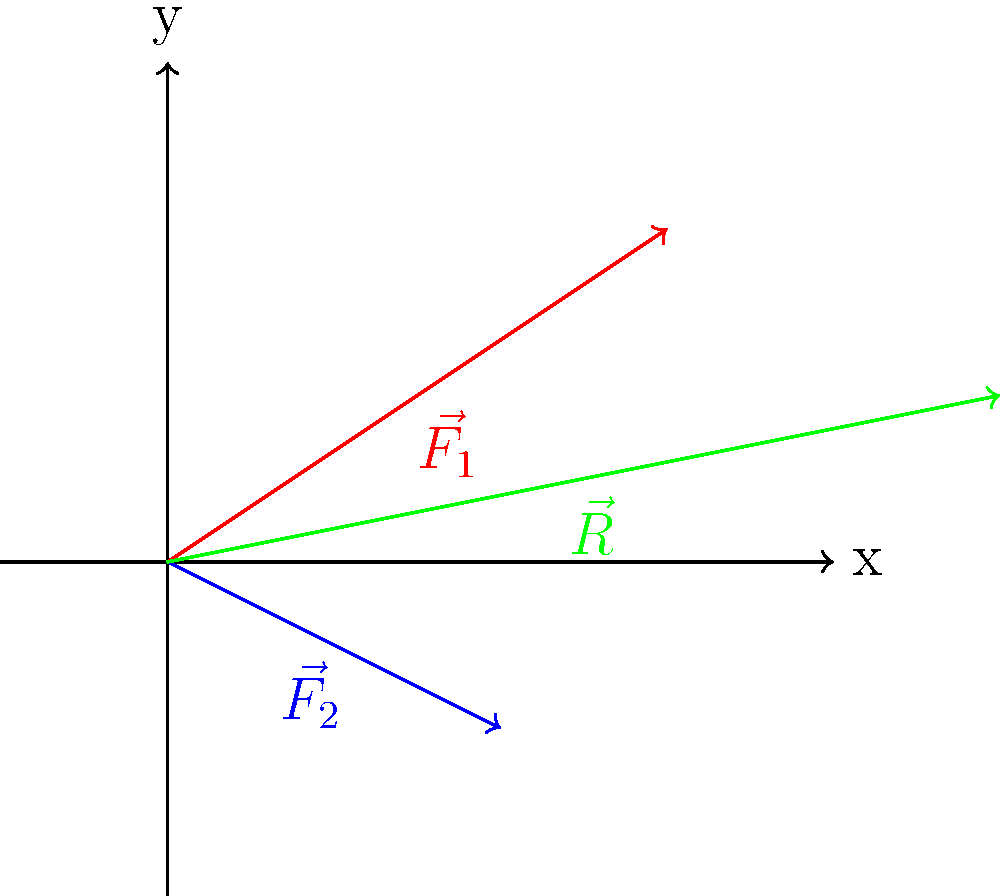As a national park manager, you're working with a biologist to study the biomechanics of a mountain lion's movement. The force vector diagram above represents two forces acting on the animal during a jump. $\vec{F_1}$ (red) represents the push-off force from the ground, while $\vec{F_2}$ (blue) represents the gravitational force. What is the magnitude of the resultant force $\vec{R}$ (green) acting on the mountain lion? To find the magnitude of the resultant force $\vec{R}$, we need to follow these steps:

1. Identify the components of the two force vectors:
   $\vec{F_1} = (3, 2)$
   $\vec{F_2} = (2, -1)$

2. Calculate the components of the resultant vector $\vec{R}$:
   $R_x = F_{1x} + F_{2x} = 3 + 2 = 5$
   $R_y = F_{1y} + F_{2y} = 2 + (-1) = 1$

3. The resultant vector $\vec{R}$ is therefore $(5, 1)$

4. Calculate the magnitude of $\vec{R}$ using the Pythagorean theorem:
   $|\vec{R}| = \sqrt{R_x^2 + R_y^2} = \sqrt{5^2 + 1^2} = \sqrt{26}$

5. Simplify:
   $|\vec{R}| = \sqrt{26} \approx 5.10$

Therefore, the magnitude of the resultant force acting on the mountain lion is approximately 5.10 units.
Answer: $\sqrt{26}$ units (or approximately 5.10 units) 